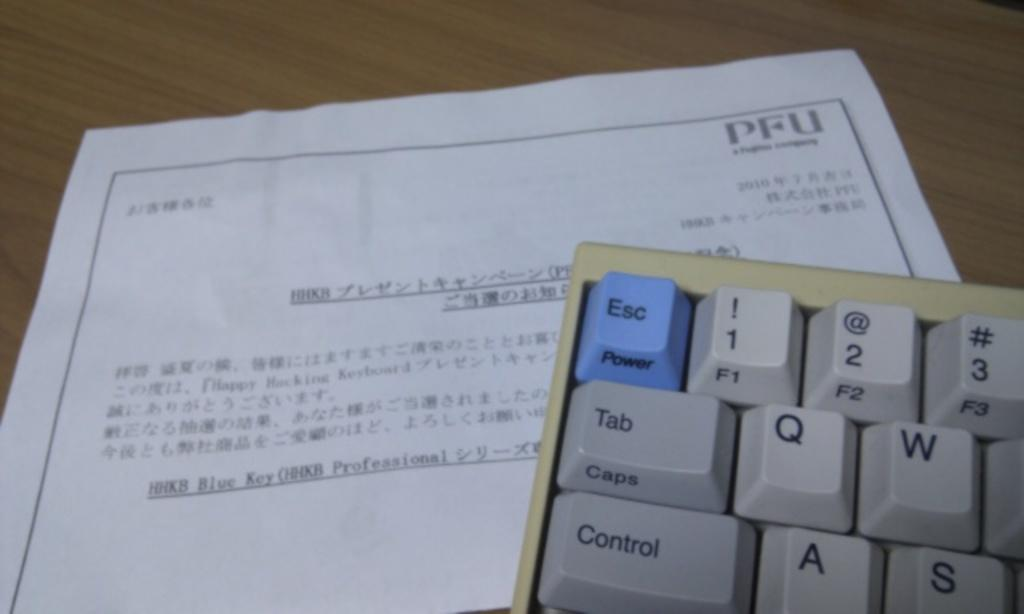<image>
Share a concise interpretation of the image provided. On a keyboard the upper left key is both esc and power. 